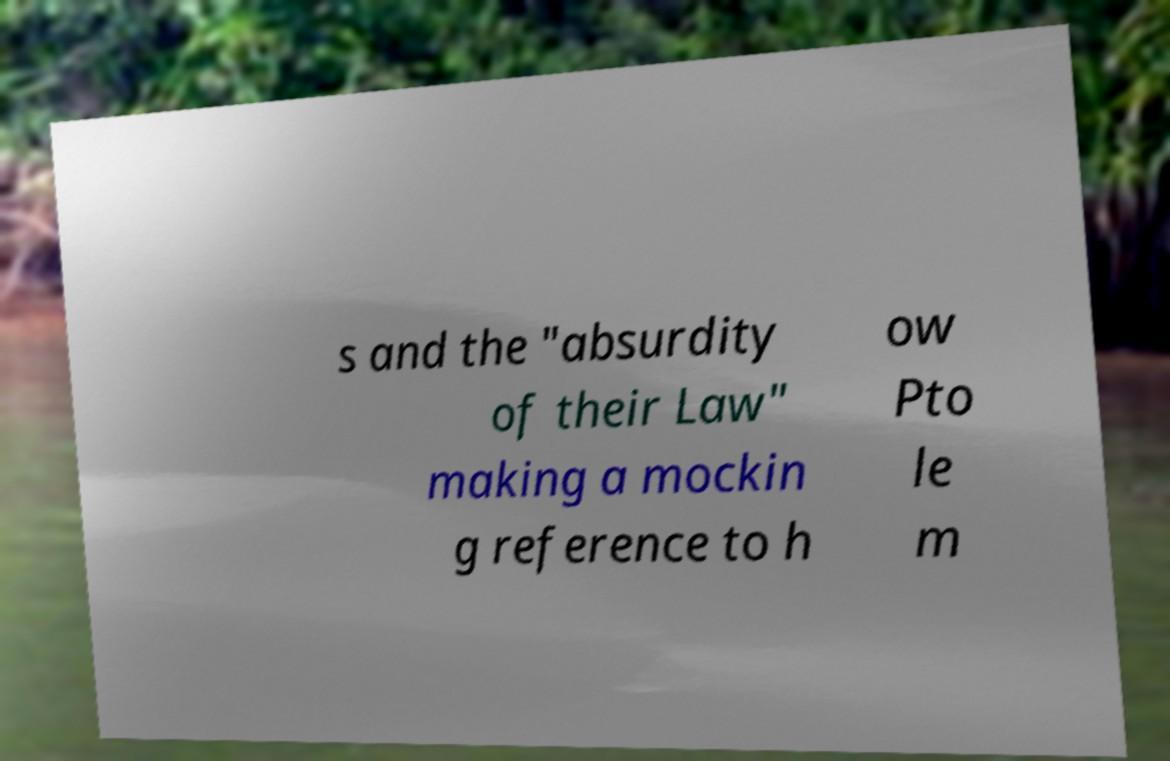Can you read and provide the text displayed in the image?This photo seems to have some interesting text. Can you extract and type it out for me? s and the "absurdity of their Law" making a mockin g reference to h ow Pto le m 